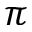<formula> <loc_0><loc_0><loc_500><loc_500>\pi</formula> 